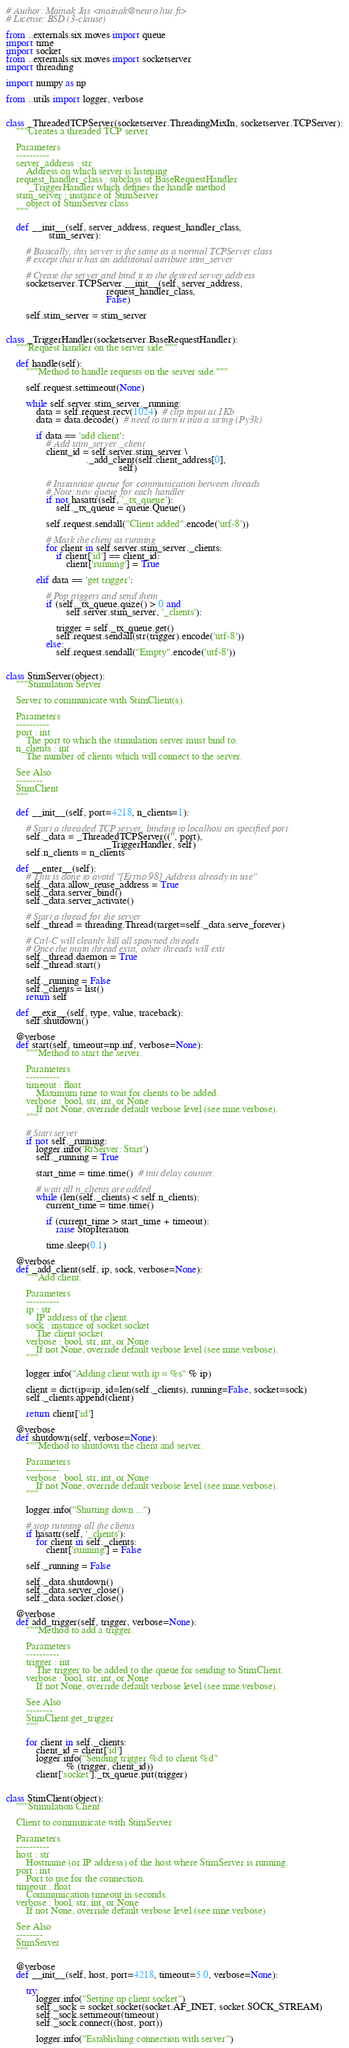<code> <loc_0><loc_0><loc_500><loc_500><_Python_># Author: Mainak Jas <mainak@neuro.hut.fi>
# License: BSD (3-clause)

from ..externals.six.moves import queue
import time
import socket
from ..externals.six.moves import socketserver
import threading

import numpy as np

from ..utils import logger, verbose


class _ThreadedTCPServer(socketserver.ThreadingMixIn, socketserver.TCPServer):
    """Creates a threaded TCP server

    Parameters
    ----------
    server_address : str
        Address on which server is listening
    request_handler_class : subclass of BaseRequestHandler
         _TriggerHandler which defines the handle method
    stim_server : instance of StimServer
        object of StimServer class
    """

    def __init__(self, server_address, request_handler_class,
                 stim_server):

        # Basically, this server is the same as a normal TCPServer class
        # except that it has an additional attribute stim_server

        # Create the server and bind it to the desired server address
        socketserver.TCPServer.__init__(self, server_address,
                                        request_handler_class,
                                        False)

        self.stim_server = stim_server


class _TriggerHandler(socketserver.BaseRequestHandler):
    """Request handler on the server side."""

    def handle(self):
        """Method to handle requests on the server side."""

        self.request.settimeout(None)

        while self.server.stim_server._running:
            data = self.request.recv(1024)  # clip input at 1Kb
            data = data.decode()  # need to turn it into a string (Py3k)

            if data == 'add client':
                # Add stim_server._client
                client_id = self.server.stim_server \
                                ._add_client(self.client_address[0],
                                             self)

                # Instantiate queue for communication between threads
                # Note: new queue for each handler
                if not hasattr(self, '_tx_queue'):
                    self._tx_queue = queue.Queue()

                self.request.sendall("Client added".encode('utf-8'))

                # Mark the client as running
                for client in self.server.stim_server._clients:
                    if client['id'] == client_id:
                        client['running'] = True

            elif data == 'get trigger':

                # Pop triggers and send them
                if (self._tx_queue.qsize() > 0 and
                        self.server.stim_server, '_clients'):

                    trigger = self._tx_queue.get()
                    self.request.sendall(str(trigger).encode('utf-8'))
                else:
                    self.request.sendall("Empty".encode('utf-8'))


class StimServer(object):
    """Stimulation Server

    Server to communicate with StimClient(s).

    Parameters
    ----------
    port : int
        The port to which the stimulation server must bind to.
    n_clients : int
        The number of clients which will connect to the server.

    See Also
    --------
    StimClient
    """

    def __init__(self, port=4218, n_clients=1):

        # Start a threaded TCP server, binding to localhost on specified port
        self._data = _ThreadedTCPServer(('', port),
                                        _TriggerHandler, self)
        self.n_clients = n_clients

    def __enter__(self):
        # This is done to avoid "[Errno 98] Address already in use"
        self._data.allow_reuse_address = True
        self._data.server_bind()
        self._data.server_activate()

        # Start a thread for the server
        self._thread = threading.Thread(target=self._data.serve_forever)

        # Ctrl-C will cleanly kill all spawned threads
        # Once the main thread exits, other threads will exit
        self._thread.daemon = True
        self._thread.start()

        self._running = False
        self._clients = list()
        return self

    def __exit__(self, type, value, traceback):
        self.shutdown()

    @verbose
    def start(self, timeout=np.inf, verbose=None):
        """Method to start the server.

        Parameters
        ----------
        timeout : float
            Maximum time to wait for clients to be added.
        verbose : bool, str, int, or None
            If not None, override default verbose level (see mne.verbose).
        """

        # Start server
        if not self._running:
            logger.info('RtServer: Start')
            self._running = True

            start_time = time.time()  # init delay counter.

            # wait till n_clients are added
            while (len(self._clients) < self.n_clients):
                current_time = time.time()

                if (current_time > start_time + timeout):
                    raise StopIteration

                time.sleep(0.1)

    @verbose
    def _add_client(self, ip, sock, verbose=None):
        """Add client.

        Parameters
        ----------
        ip : str
            IP address of the client.
        sock : instance of socket.socket
            The client socket.
        verbose : bool, str, int, or None
            If not None, override default verbose level (see mne.verbose).
        """

        logger.info("Adding client with ip = %s" % ip)

        client = dict(ip=ip, id=len(self._clients), running=False, socket=sock)
        self._clients.append(client)

        return client['id']

    @verbose
    def shutdown(self, verbose=None):
        """Method to shutdown the client and server.

        Parameters
        ----------
        verbose : bool, str, int, or None
            If not None, override default verbose level (see mne.verbose).
        """

        logger.info("Shutting down ...")

        # stop running all the clients
        if hasattr(self, '_clients'):
            for client in self._clients:
                client['running'] = False

        self._running = False

        self._data.shutdown()
        self._data.server_close()
        self._data.socket.close()

    @verbose
    def add_trigger(self, trigger, verbose=None):
        """Method to add a trigger.

        Parameters
        ----------
        trigger : int
            The trigger to be added to the queue for sending to StimClient.
        verbose : bool, str, int, or None
            If not None, override default verbose level (see mne.verbose).

        See Also
        --------
        StimClient.get_trigger
        """

        for client in self._clients:
            client_id = client['id']
            logger.info("Sending trigger %d to client %d"
                        % (trigger, client_id))
            client['socket']._tx_queue.put(trigger)


class StimClient(object):
    """Stimulation Client

    Client to communicate with StimServer

    Parameters
    ----------
    host : str
        Hostname (or IP address) of the host where StimServer is running.
    port : int
        Port to use for the connection.
    timeout : float
        Communication timeout in seconds.
    verbose : bool, str, int, or None
        If not None, override default verbose level (see mne.verbose).

    See Also
    --------
    StimServer
    """

    @verbose
    def __init__(self, host, port=4218, timeout=5.0, verbose=None):

        try:
            logger.info("Setting up client socket")
            self._sock = socket.socket(socket.AF_INET, socket.SOCK_STREAM)
            self._sock.settimeout(timeout)
            self._sock.connect((host, port))

            logger.info("Establishing connection with server")</code> 